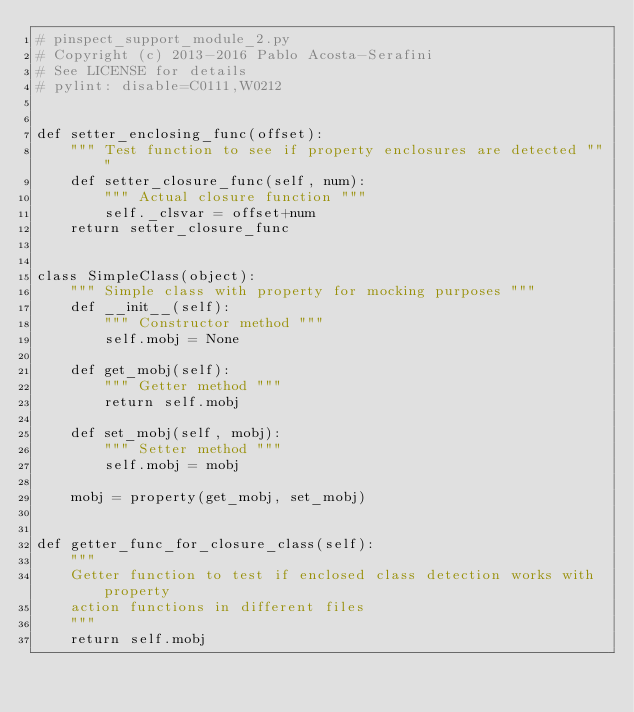<code> <loc_0><loc_0><loc_500><loc_500><_Python_># pinspect_support_module_2.py
# Copyright (c) 2013-2016 Pablo Acosta-Serafini
# See LICENSE for details
# pylint: disable=C0111,W0212


def setter_enclosing_func(offset):
    """ Test function to see if property enclosures are detected """
    def setter_closure_func(self, num):
        """ Actual closure function """
        self._clsvar = offset+num
    return setter_closure_func


class SimpleClass(object):
    """ Simple class with property for mocking purposes """
    def __init__(self):
        """ Constructor method """
        self.mobj = None

    def get_mobj(self):
        """ Getter method """
        return self.mobj

    def set_mobj(self, mobj):
        """ Setter method """
        self.mobj = mobj

    mobj = property(get_mobj, set_mobj)


def getter_func_for_closure_class(self):
    """
    Getter function to test if enclosed class detection works with property
    action functions in different files
    """
    return self.mobj
</code> 